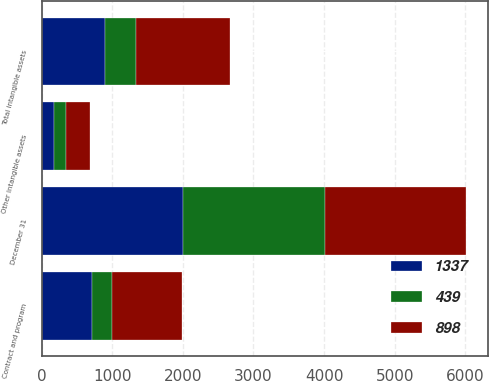<chart> <loc_0><loc_0><loc_500><loc_500><stacked_bar_chart><ecel><fcel>December 31<fcel>Contract and program<fcel>Other intangible assets<fcel>Total intangible assets<nl><fcel>898<fcel>2005<fcel>996<fcel>341<fcel>1337<nl><fcel>439<fcel>2005<fcel>277<fcel>162<fcel>439<nl><fcel>1337<fcel>2005<fcel>719<fcel>179<fcel>898<nl></chart> 